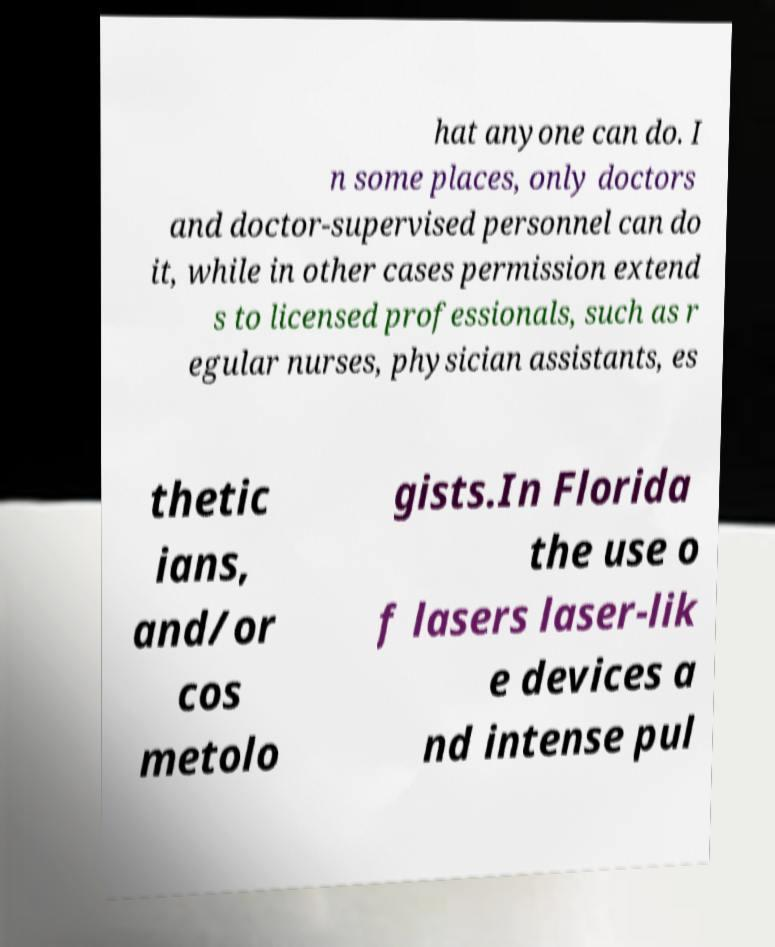Can you read and provide the text displayed in the image?This photo seems to have some interesting text. Can you extract and type it out for me? hat anyone can do. I n some places, only doctors and doctor-supervised personnel can do it, while in other cases permission extend s to licensed professionals, such as r egular nurses, physician assistants, es thetic ians, and/or cos metolo gists.In Florida the use o f lasers laser-lik e devices a nd intense pul 